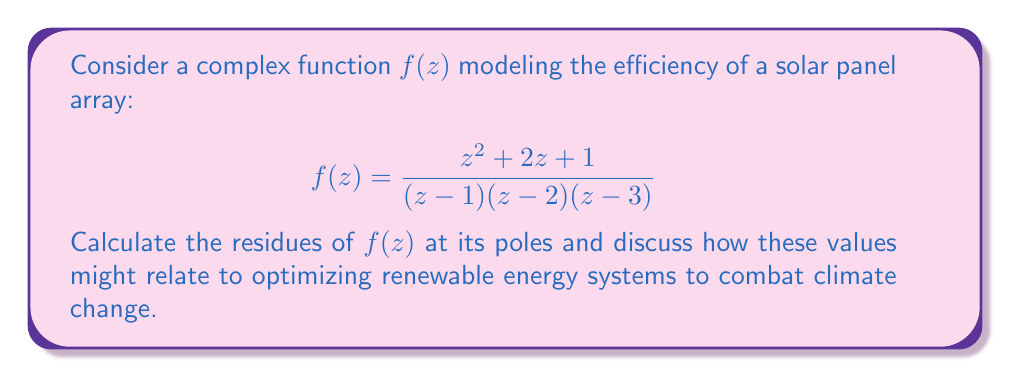Can you answer this question? To calculate the residues, we need to find the poles of $f(z)$ and evaluate the residue at each pole.

1. Identify the poles:
   The poles are at $z = 1$, $z = 2$, and $z = 3$, all of which are simple poles.

2. Calculate the residues using the formula for simple poles:
   $$\text{Res}(f,a) = \lim_{z \to a} (z-a)f(z)$$

   a) For $z = 1$:
      $$\text{Res}(f,1) = \lim_{z \to 1} (z-1)\frac{z^2 + 2z + 1}{(z-1)(z-2)(z-3)}$$
      $$= \lim_{z \to 1} \frac{z^2 + 2z + 1}{(z-2)(z-3)} = \frac{1^2 + 2(1) + 1}{(1-2)(1-3)} = \frac{4}{2} = 2$$

   b) For $z = 2$:
      $$\text{Res}(f,2) = \lim_{z \to 2} (z-2)\frac{z^2 + 2z + 1}{(z-1)(z-2)(z-3)}$$
      $$= \lim_{z \to 2} \frac{z^2 + 2z + 1}{(z-1)(z-3)} = \frac{2^2 + 2(2) + 1}{(2-1)(2-3)} = \frac{9}{-1} = -9$$

   c) For $z = 3$:
      $$\text{Res}(f,3) = \lim_{z \to 3} (z-3)\frac{z^2 + 2z + 1}{(z-1)(z-2)(z-3)}$$
      $$= \lim_{z \to 3} \frac{z^2 + 2z + 1}{(z-1)(z-2)} = \frac{3^2 + 2(3) + 1}{(3-1)(3-2)} = \frac{16}{2} = 8$$

In the context of renewable energy systems, these residues could represent critical points in the efficiency curve of the solar panel array. The positive residues (2 and 8) might indicate optimal operating conditions or energy output peaks, while the negative residue (-9) could represent a point of reduced efficiency or energy loss. Understanding these critical points can help in designing and optimizing solar energy systems for maximum efficiency, thereby contributing to the fight against climate change.
Answer: The residues of $f(z)$ at its poles are:
$\text{Res}(f,1) = 2$
$\text{Res}(f,2) = -9$
$\text{Res}(f,3) = 8$ 